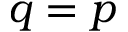Convert formula to latex. <formula><loc_0><loc_0><loc_500><loc_500>q = p</formula> 